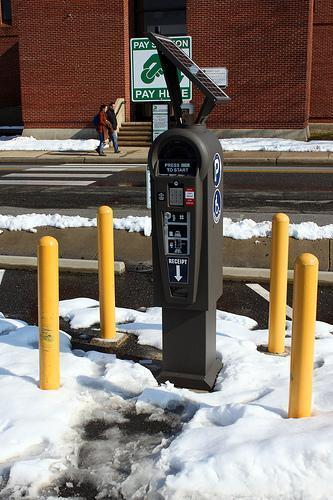How many people are standing near the meter machine?
Give a very brief answer. 0. 